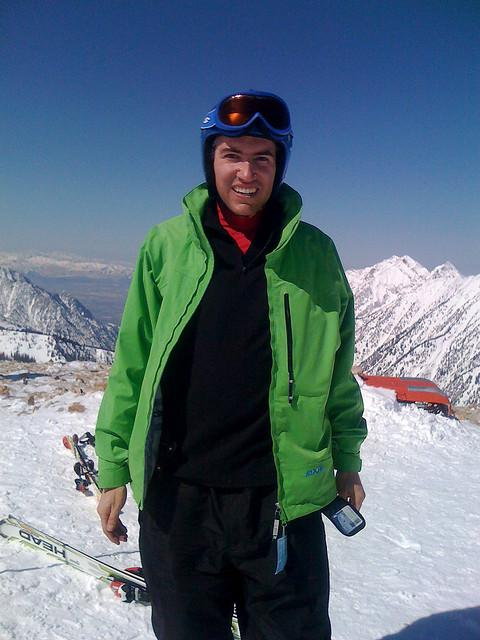What type of telephone is he using?

Choices:
A) pay
B) cellular
C) rotary
D) landline cellular 